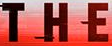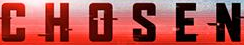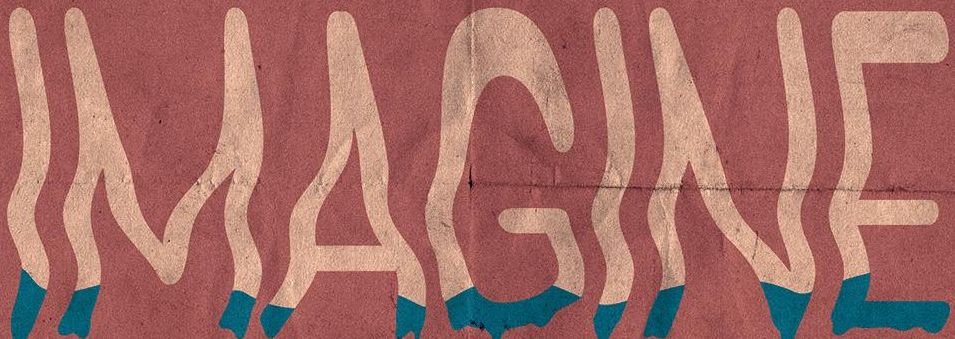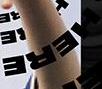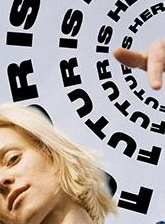Transcribe the words shown in these images in order, separated by a semicolon. THE; CHOSEN; IMAGINE; HERE; FUTURIS 